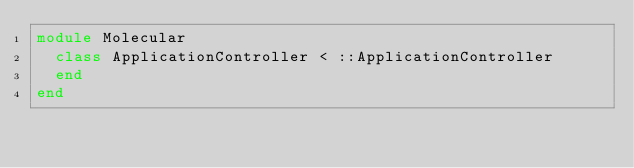<code> <loc_0><loc_0><loc_500><loc_500><_Ruby_>module Molecular
  class ApplicationController < ::ApplicationController
  end
end
</code> 